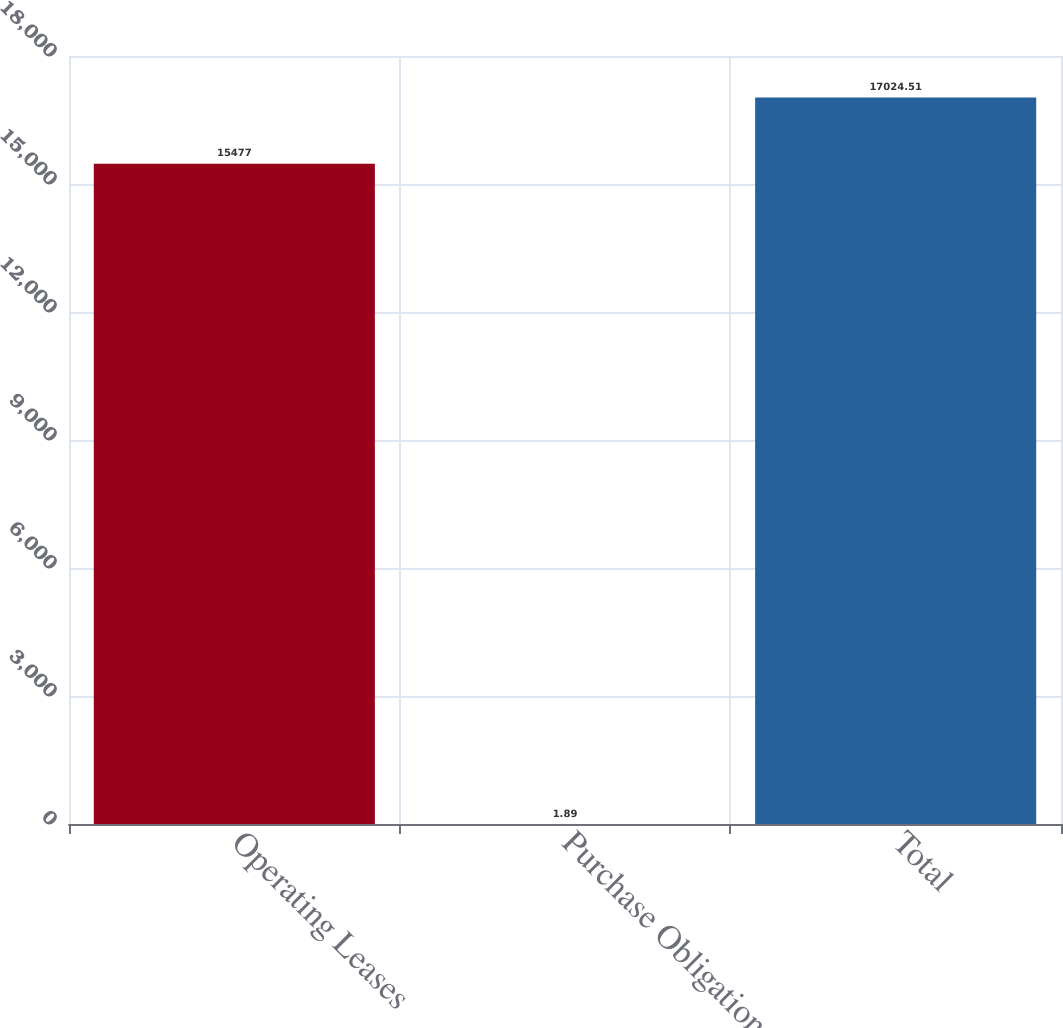Convert chart. <chart><loc_0><loc_0><loc_500><loc_500><bar_chart><fcel>Operating Leases<fcel>Purchase Obligations<fcel>Total<nl><fcel>15477<fcel>1.89<fcel>17024.5<nl></chart> 